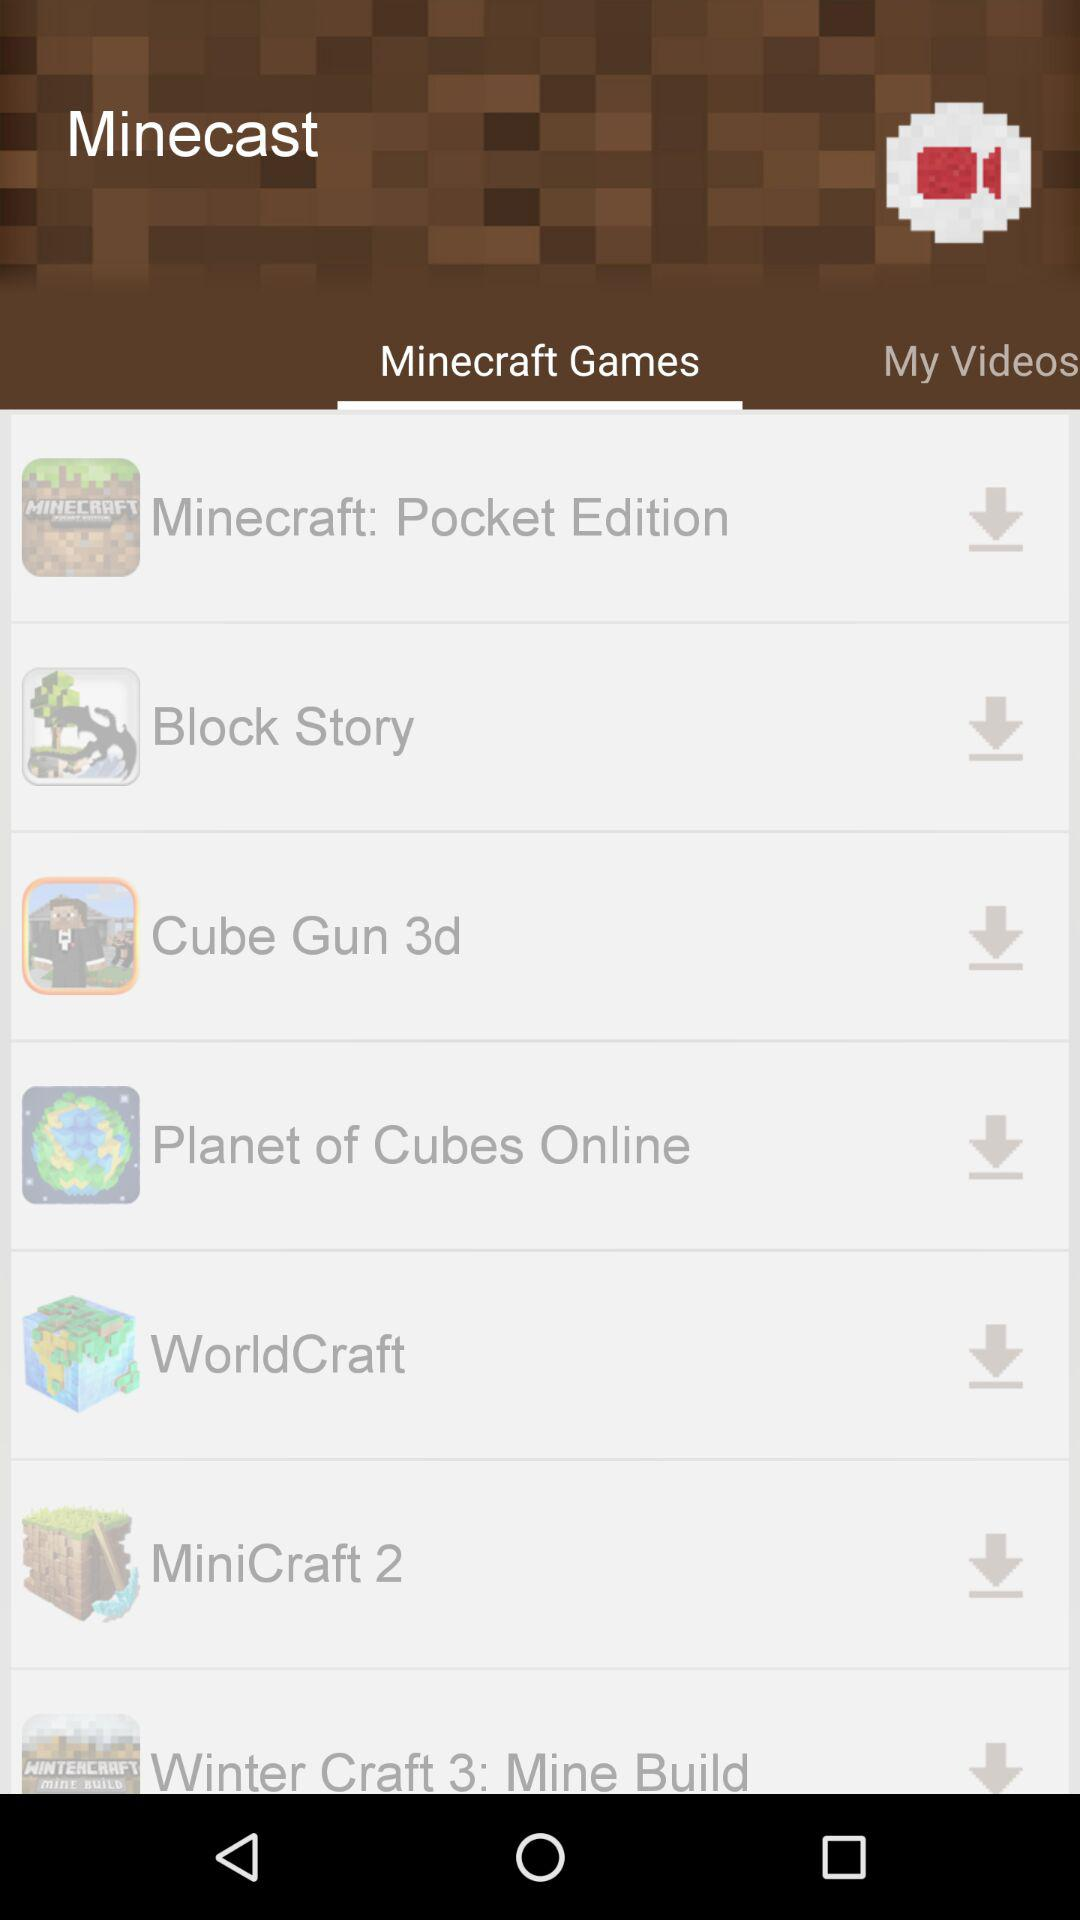Which option is selected? The selected option is "Minecraft Games". 